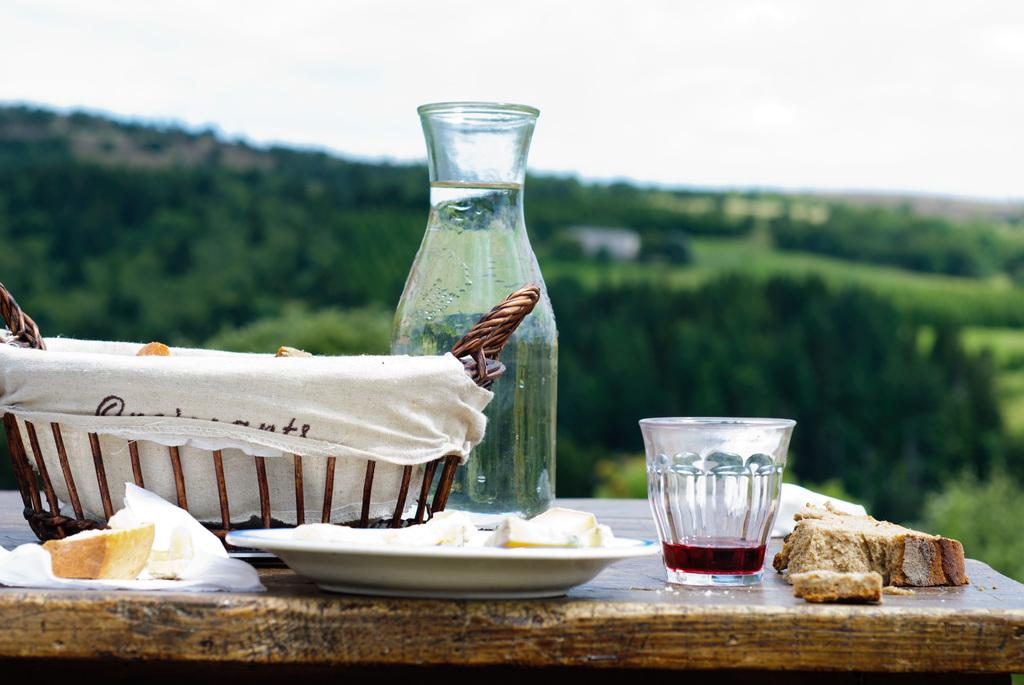What is located at the bottom of the image? There is a table at the bottom of the image. What items can be seen on the table? There are glasses, a jug, plates, a basket, and bread on the table. What can be seen in the background of the image? There are trees, hills, and the sky visible in the background of the image. What type of shoe can be seen in the image? There is no shoe present in the image. What division of labor is depicted in the image? The image does not depict any division of labor; it shows a table with various items and a background with trees, hills, and the sky. 